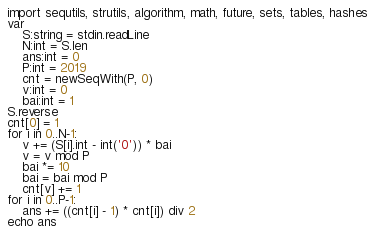Convert code to text. <code><loc_0><loc_0><loc_500><loc_500><_Nim_>import sequtils, strutils, algorithm, math, future, sets, tables, hashes
var 
    S:string = stdin.readLine
    N:int = S.len
    ans:int = 0
    P:int = 2019
    cnt = newSeqWith(P, 0)
    v:int = 0
    bai:int = 1
S.reverse
cnt[0] = 1
for i in 0..N-1:
    v += (S[i].int - int('0')) * bai
    v = v mod P
    bai *= 10
    bai = bai mod P
    cnt[v] += 1
for i in 0..P-1:
    ans += ((cnt[i] - 1) * cnt[i]) div 2
echo ans</code> 